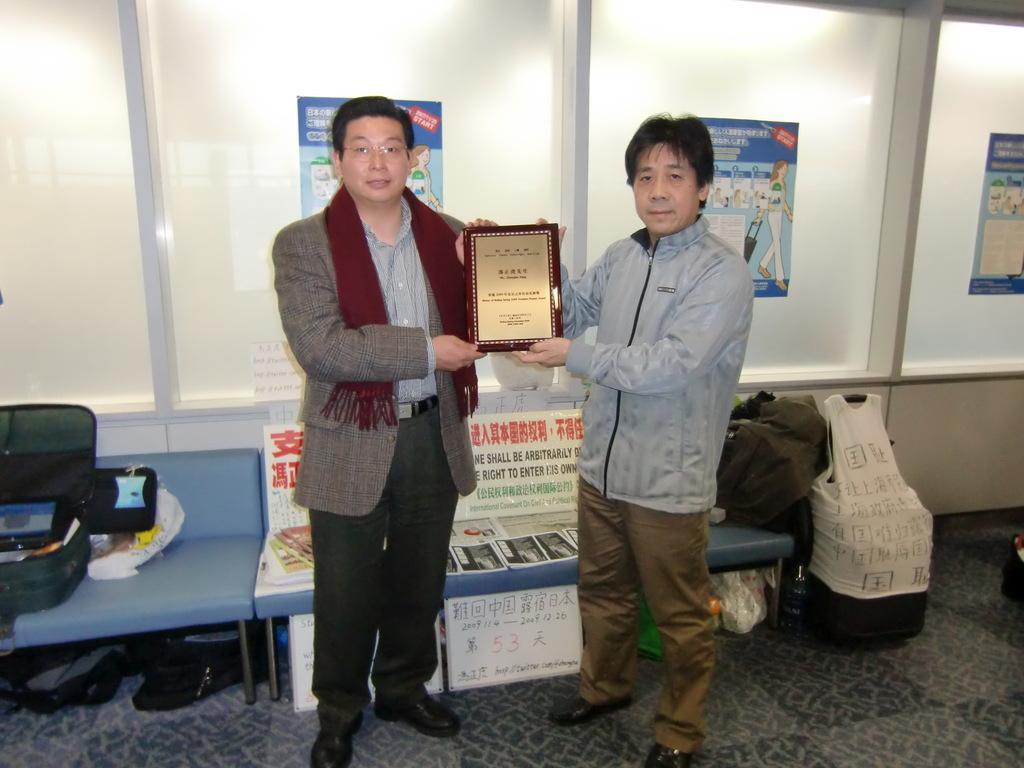Can you describe this image briefly? On the background we can see posts over a window glasses. Here we can see both men holding a award in their hands. Behind to them we can see chairs and on the chairs there is a luggage bag and a backpack. On the floor we can see a luggage bag. 